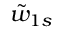<formula> <loc_0><loc_0><loc_500><loc_500>\tilde { w } _ { 1 s }</formula> 